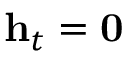<formula> <loc_0><loc_0><loc_500><loc_500>h _ { t } = 0</formula> 